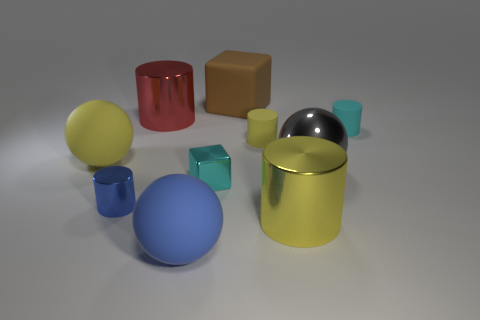Subtract all tiny cylinders. How many cylinders are left? 2 Subtract 1 cylinders. How many cylinders are left? 4 Subtract all purple cubes. How many yellow cylinders are left? 2 Subtract all cyan cylinders. How many cylinders are left? 4 Subtract all cubes. How many objects are left? 8 Add 7 shiny cylinders. How many shiny cylinders are left? 10 Add 5 tiny metal spheres. How many tiny metal spheres exist? 5 Subtract 0 purple blocks. How many objects are left? 10 Subtract all cyan spheres. Subtract all purple blocks. How many spheres are left? 3 Subtract all big brown blocks. Subtract all blue rubber balls. How many objects are left? 8 